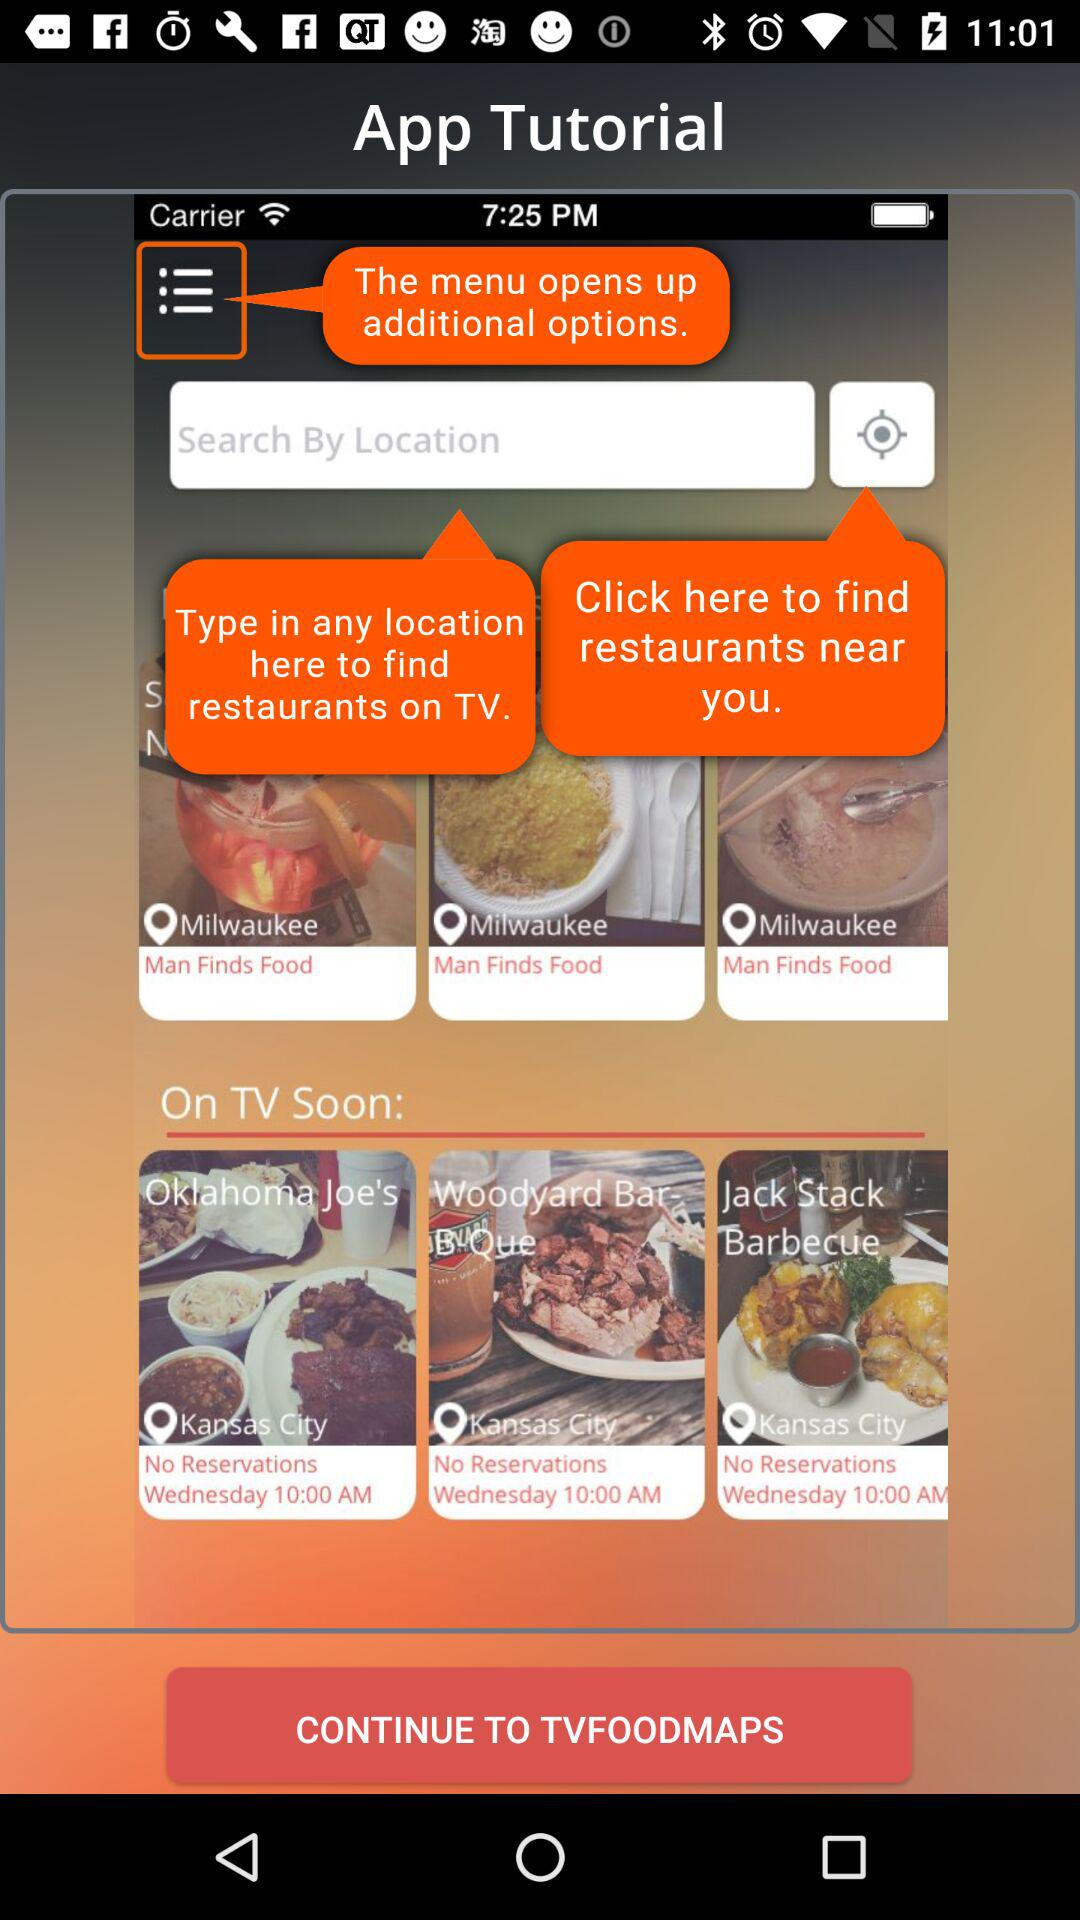What is the searched location in the text field?
When the provided information is insufficient, respond with <no answer>. <no answer> 